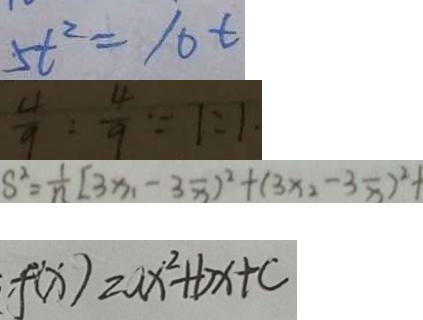Convert formula to latex. <formula><loc_0><loc_0><loc_500><loc_500>5 t ^ { 2 } = 1 0 t 
 \frac { 4 } { 9 } : \frac { 4 } { 9 } \because 1 : 1 . 
 S ^ { 2 } = \frac { 1 } { n } [ 3 x _ { 1 } - 3 \overline { x } ) ^ { 2 } + ( 3 x _ { 2 } - 3 \overline { x } ) ^ { 2 } + 
 f ( x ) = a x ^ { 2 } + b x + c</formula> 